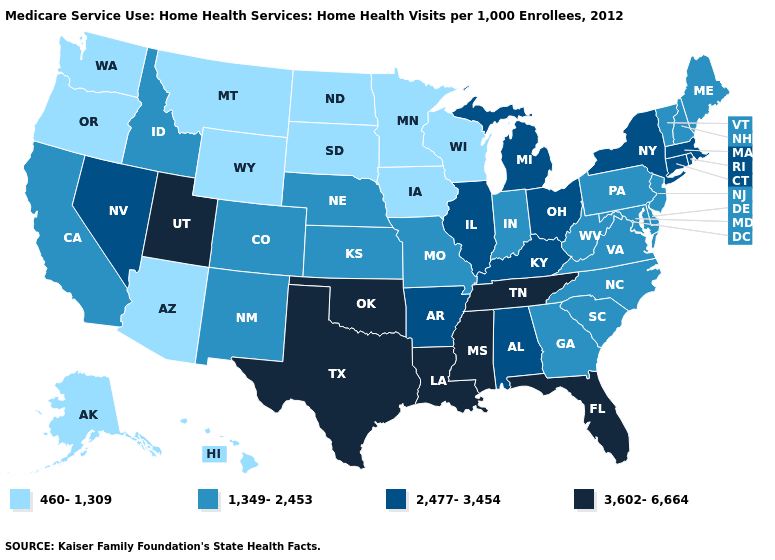What is the value of Missouri?
Answer briefly. 1,349-2,453. Which states hav the highest value in the West?
Quick response, please. Utah. Does Arizona have a lower value than Iowa?
Write a very short answer. No. Which states have the lowest value in the West?
Short answer required. Alaska, Arizona, Hawaii, Montana, Oregon, Washington, Wyoming. Which states have the lowest value in the USA?
Quick response, please. Alaska, Arizona, Hawaii, Iowa, Minnesota, Montana, North Dakota, Oregon, South Dakota, Washington, Wisconsin, Wyoming. Name the states that have a value in the range 1,349-2,453?
Be succinct. California, Colorado, Delaware, Georgia, Idaho, Indiana, Kansas, Maine, Maryland, Missouri, Nebraska, New Hampshire, New Jersey, New Mexico, North Carolina, Pennsylvania, South Carolina, Vermont, Virginia, West Virginia. Name the states that have a value in the range 2,477-3,454?
Short answer required. Alabama, Arkansas, Connecticut, Illinois, Kentucky, Massachusetts, Michigan, Nevada, New York, Ohio, Rhode Island. Does Minnesota have the same value as Georgia?
Quick response, please. No. What is the highest value in the South ?
Short answer required. 3,602-6,664. What is the value of Massachusetts?
Be succinct. 2,477-3,454. Does Indiana have a higher value than Iowa?
Give a very brief answer. Yes. Is the legend a continuous bar?
Short answer required. No. What is the value of Arkansas?
Quick response, please. 2,477-3,454. Does Mississippi have the highest value in the USA?
Keep it brief. Yes. Does Tennessee have a higher value than Utah?
Give a very brief answer. No. 